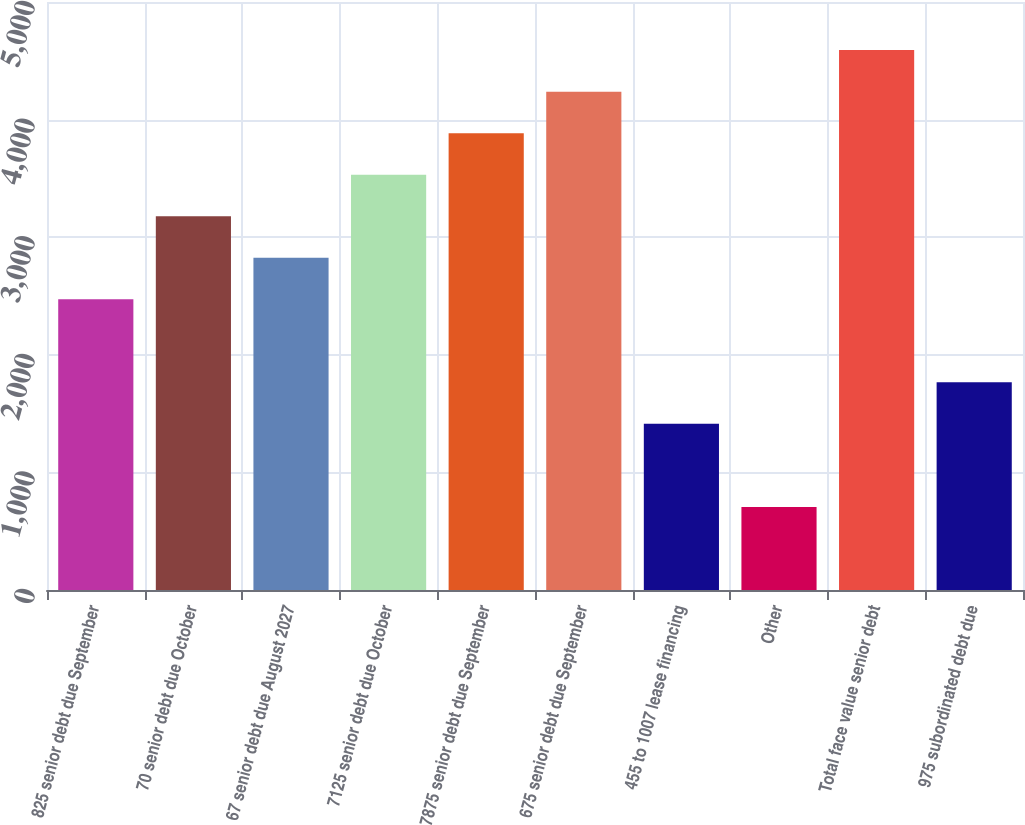Convert chart to OTSL. <chart><loc_0><loc_0><loc_500><loc_500><bar_chart><fcel>825 senior debt due September<fcel>70 senior debt due October<fcel>67 senior debt due August 2027<fcel>7125 senior debt due October<fcel>7875 senior debt due September<fcel>675 senior debt due September<fcel>455 to 1007 lease financing<fcel>Other<fcel>Total face value senior debt<fcel>975 subordinated debt due<nl><fcel>2472.3<fcel>3178.5<fcel>2825.4<fcel>3531.6<fcel>3884.7<fcel>4237.8<fcel>1413<fcel>706.8<fcel>4590.9<fcel>1766.1<nl></chart> 